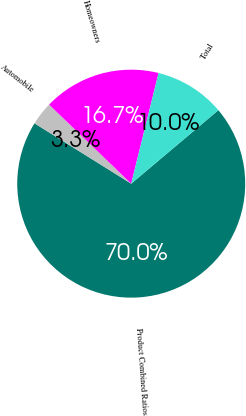Convert chart to OTSL. <chart><loc_0><loc_0><loc_500><loc_500><pie_chart><fcel>Product Combined Ratios<fcel>Automobile<fcel>Homeowners<fcel>Total<nl><fcel>70.03%<fcel>3.32%<fcel>16.66%<fcel>9.99%<nl></chart> 